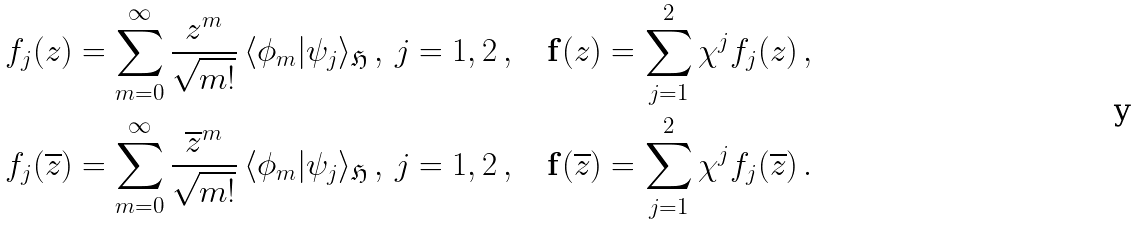Convert formula to latex. <formula><loc_0><loc_0><loc_500><loc_500>& f _ { j } ( z ) = \sum _ { m = 0 } ^ { \infty } \frac { z ^ { m } } { \sqrt { m ! } } \, \langle \phi _ { m } | \psi _ { j } \rangle _ { \mathfrak H } \, , \, j = 1 , 2 \, , \quad \mathbf f ( z ) = \sum _ { j = 1 } ^ { 2 } \chi ^ { j } f _ { j } ( z ) \, , \\ & f _ { j } ( \overline { z } ) = \sum _ { m = 0 } ^ { \infty } \frac { \overline { z } ^ { m } } { \sqrt { m ! } } \, \langle \phi _ { m } | \psi _ { j } \rangle _ { \mathfrak H } \, , \, j = 1 , 2 \, , \quad \mathbf f ( \overline { z } ) = \sum _ { j = 1 } ^ { 2 } \chi ^ { j } f _ { j } ( \overline { z } ) \, .</formula> 